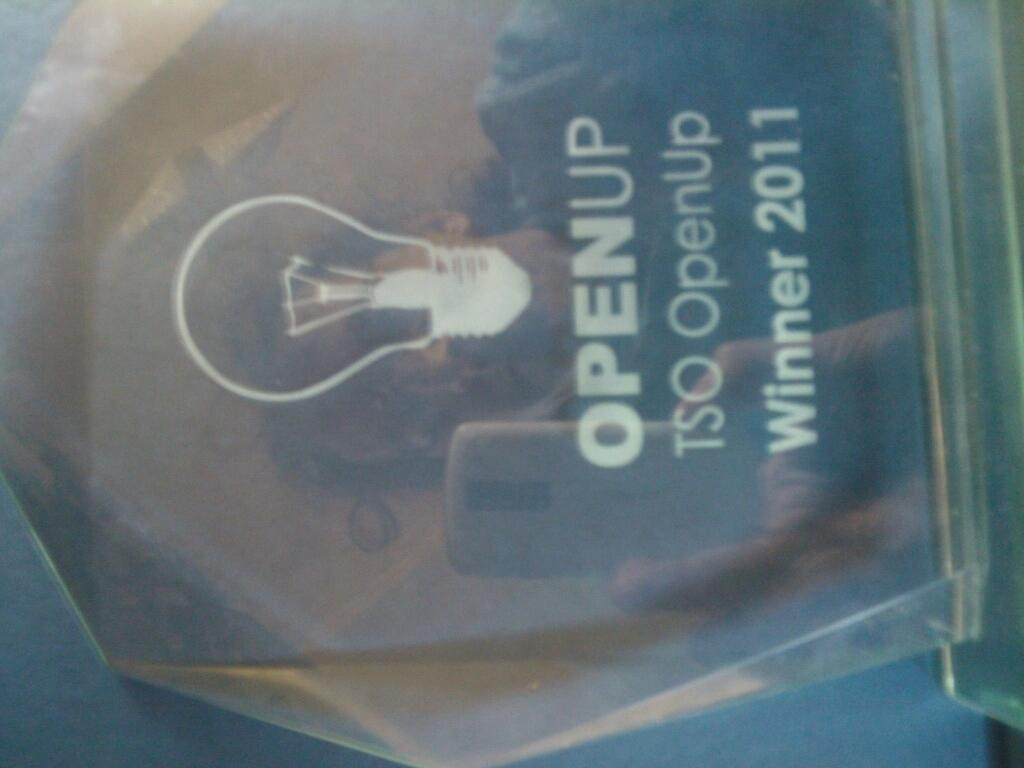Provide a one-sentence caption for the provided image. An award with the words OpenUp winner 2011 on it. 